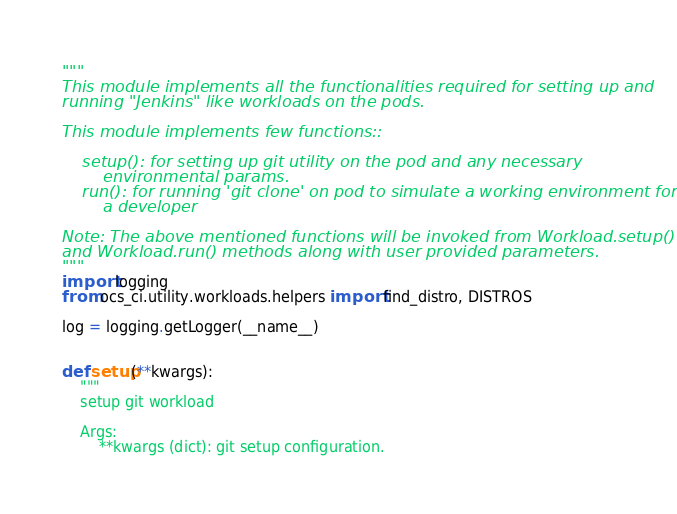Convert code to text. <code><loc_0><loc_0><loc_500><loc_500><_Python_>"""
This module implements all the functionalities required for setting up and
running "Jenkins" like workloads on the pods.

This module implements few functions::

    setup(): for setting up git utility on the pod and any necessary
        environmental params.
    run(): for running 'git clone' on pod to simulate a working environment for
        a developer

Note: The above mentioned functions will be invoked from Workload.setup()
and Workload.run() methods along with user provided parameters.
"""
import logging
from ocs_ci.utility.workloads.helpers import find_distro, DISTROS

log = logging.getLogger(__name__)


def setup(**kwargs):
    """
    setup git workload

    Args:
        **kwargs (dict): git setup configuration.</code> 